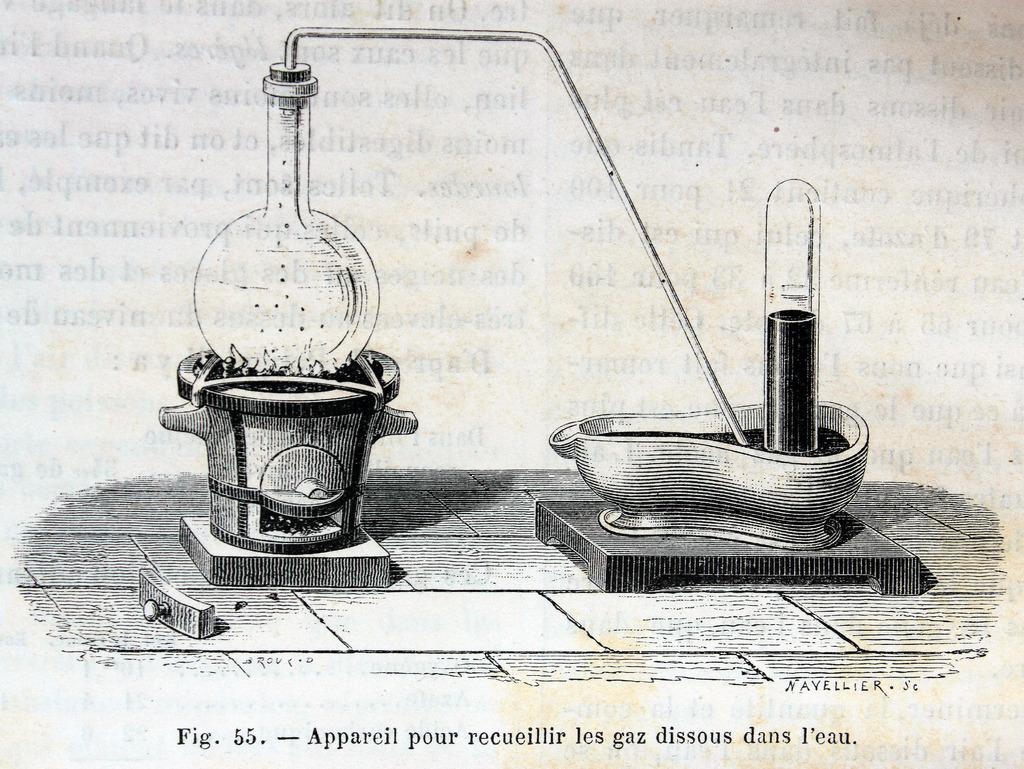<image>
Offer a succinct explanation of the picture presented. an illustration of fig. 55 with a bathtub 